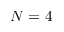Convert formula to latex. <formula><loc_0><loc_0><loc_500><loc_500>N = 4</formula> 